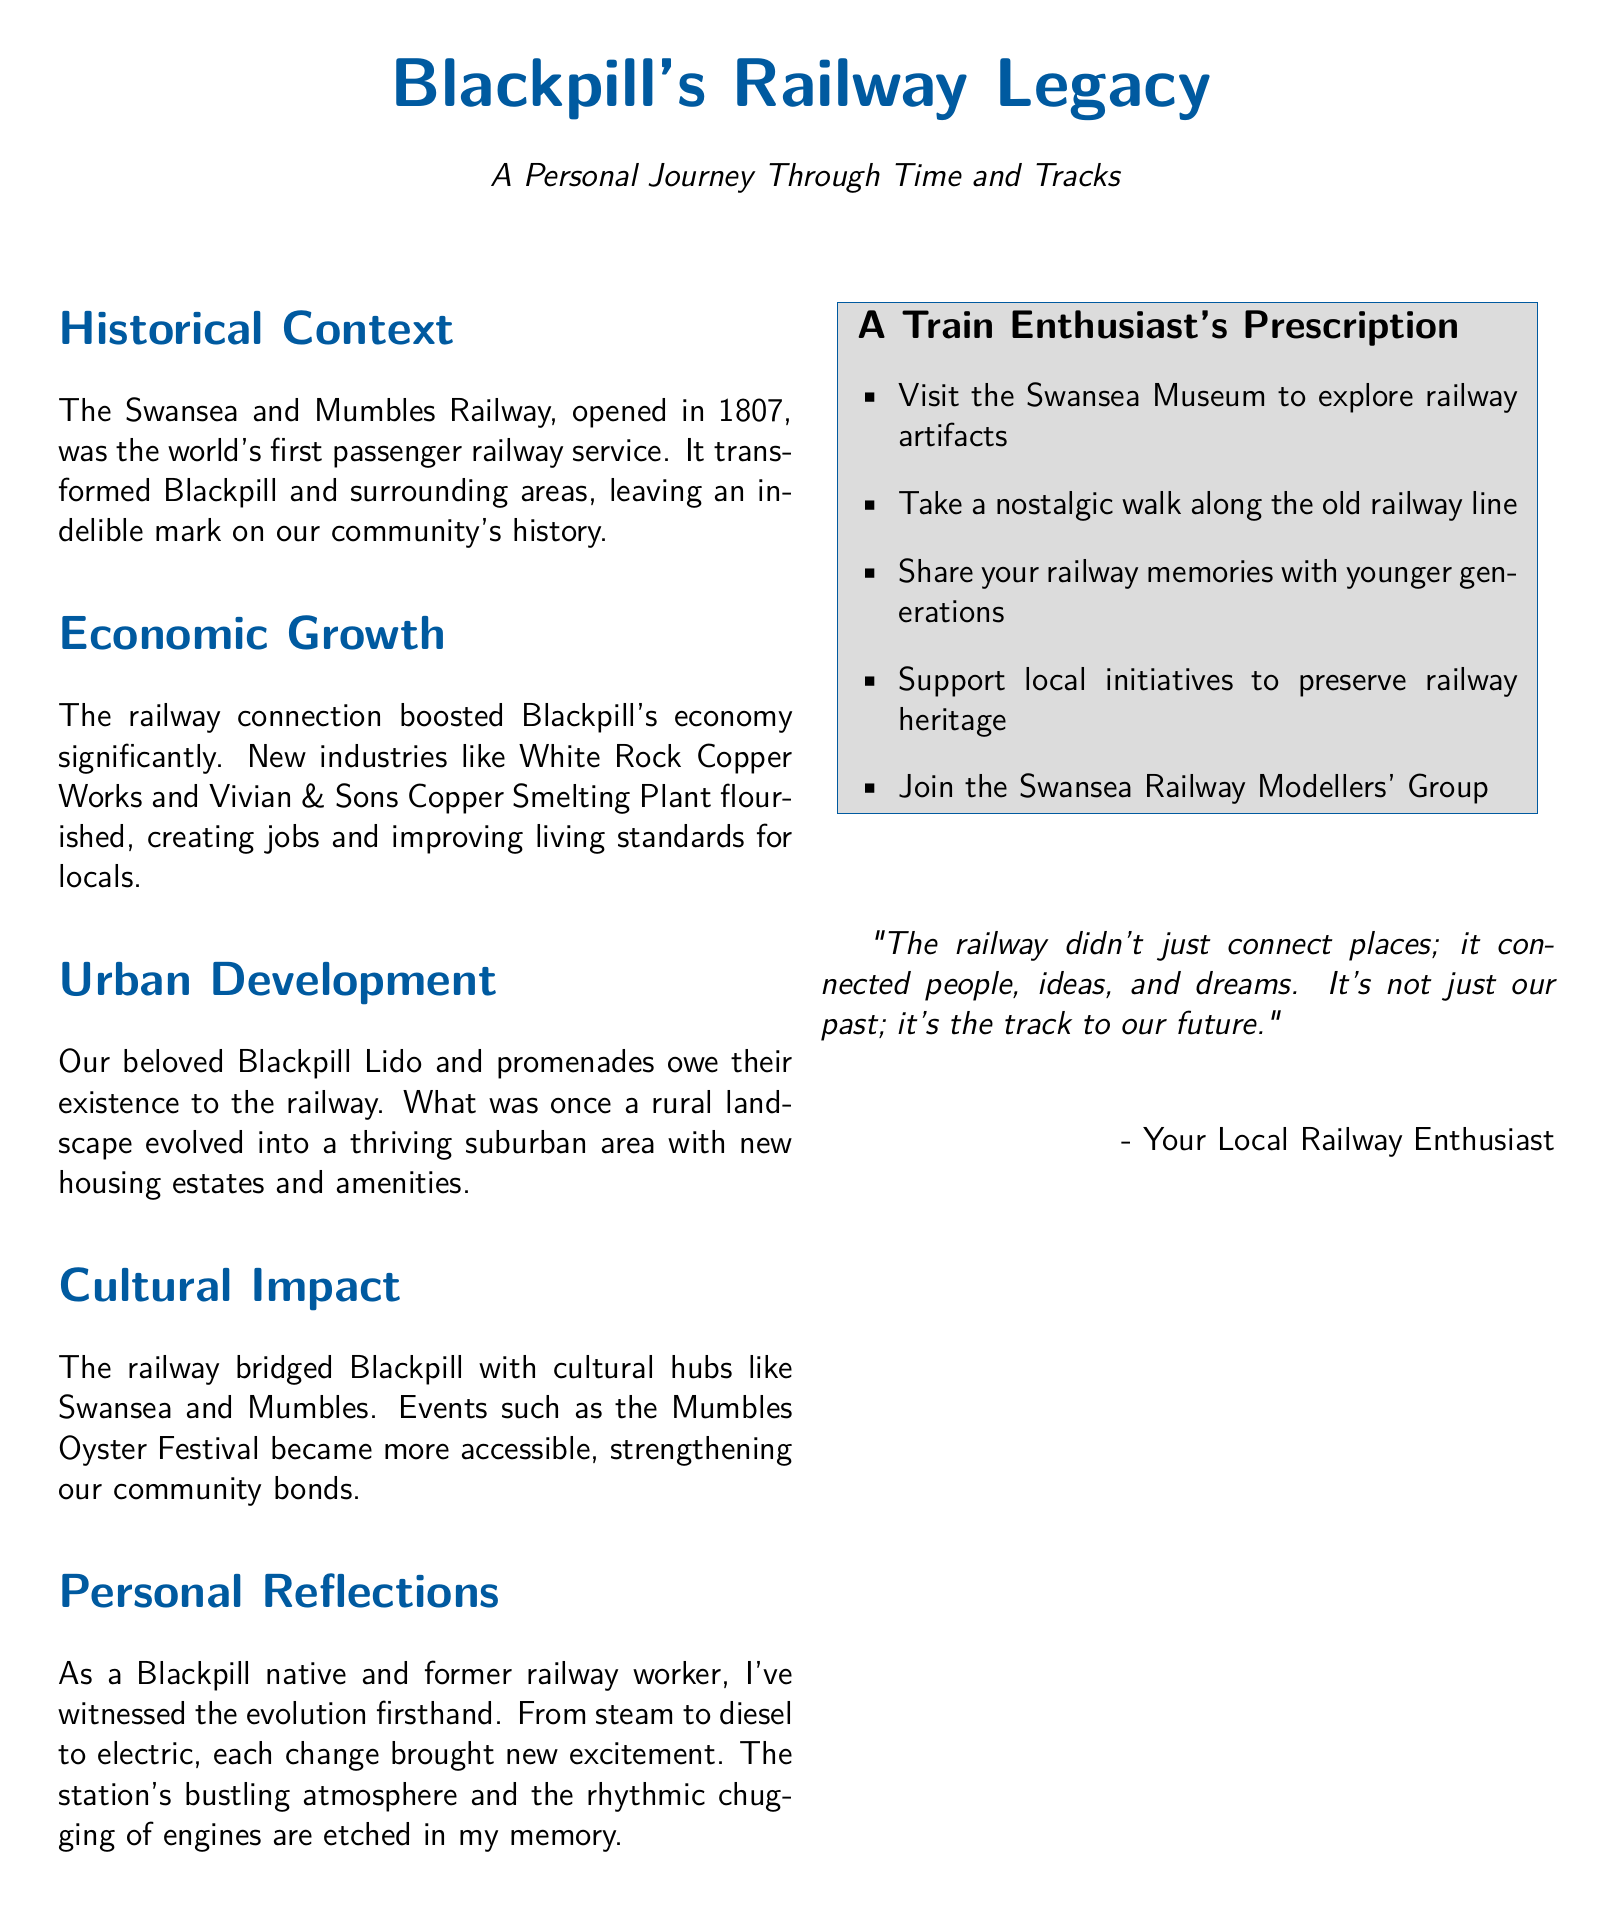What year was the Swansea and Mumbles Railway opened? The document states that the railway was opened in 1807.
Answer: 1807 What industry flourished due to the railway connection in Blackpill? The document mentions that the White Rock Copper Works and Vivian & Sons Copper Smelting Plant were significant industries that prospered.
Answer: Copper Works What community feature was developed due to the railway, according to the document? The document indicates that the Blackpill Lido and promenades owe their existence to the railway.
Answer: Blackpill Lido What cultural event became more accessible due to the railway? The document refers to the Mumbles Oyster Festival as an event that was made more accessible.
Answer: Mumbles Oyster Festival Who wrote the document? The author identifies themselves as "Your Local Railway Enthusiast" at the end of the document.
Answer: Your Local Railway Enthusiast What is one suggested activity for train enthusiasts in the document? The document lists several activities, including visiting the Swansea Museum to explore railway artifacts.
Answer: Visit the Swansea Museum How does the author describe the impact of the railway on the community? The author notes that the railway connected people, ideas, and dreams.
Answer: Connected people, ideas, and dreams What type of document is this? The structure and content indicate it is a prescription, specifically tailored to railway enthusiasts.
Answer: Prescription 